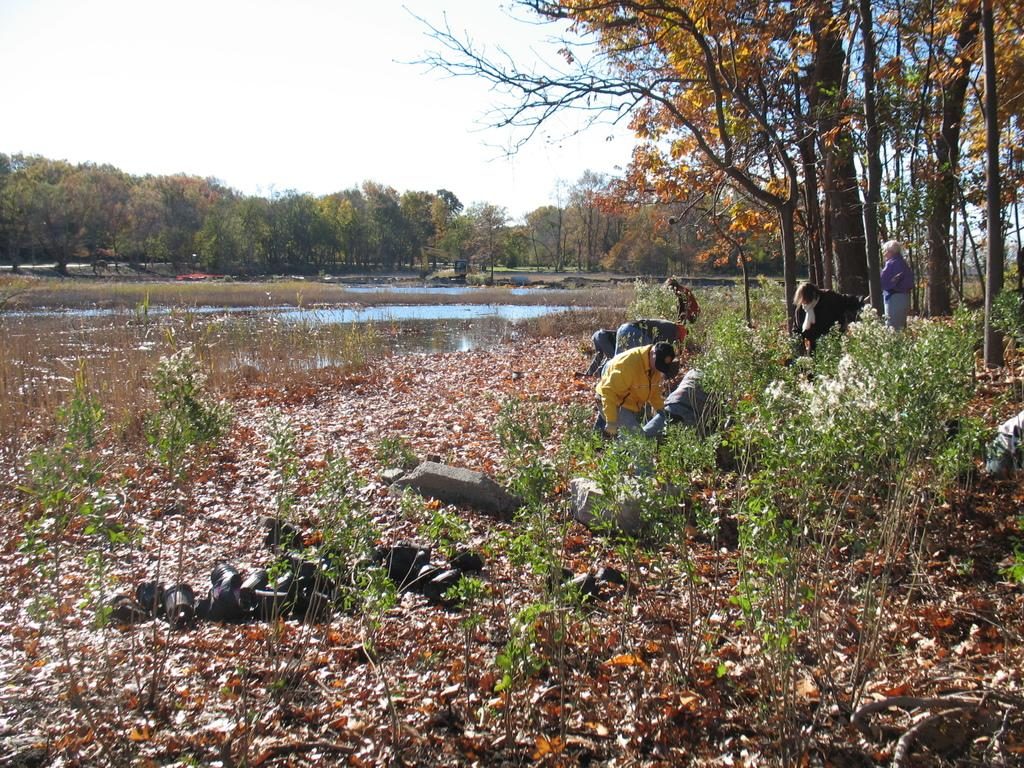What type of natural elements can be seen in the image? There are stones, plants, dry leaves, water, trees, and the sky visible in the image. Are there any living beings present in the image? Yes, there are people in the image. What is the condition of the water in the image? The water is visible in the image, but no specific condition is mentioned. What type of smell can be detected from the lake in the image? There is no lake present in the image, so it is not possible to determine any associated smell. 